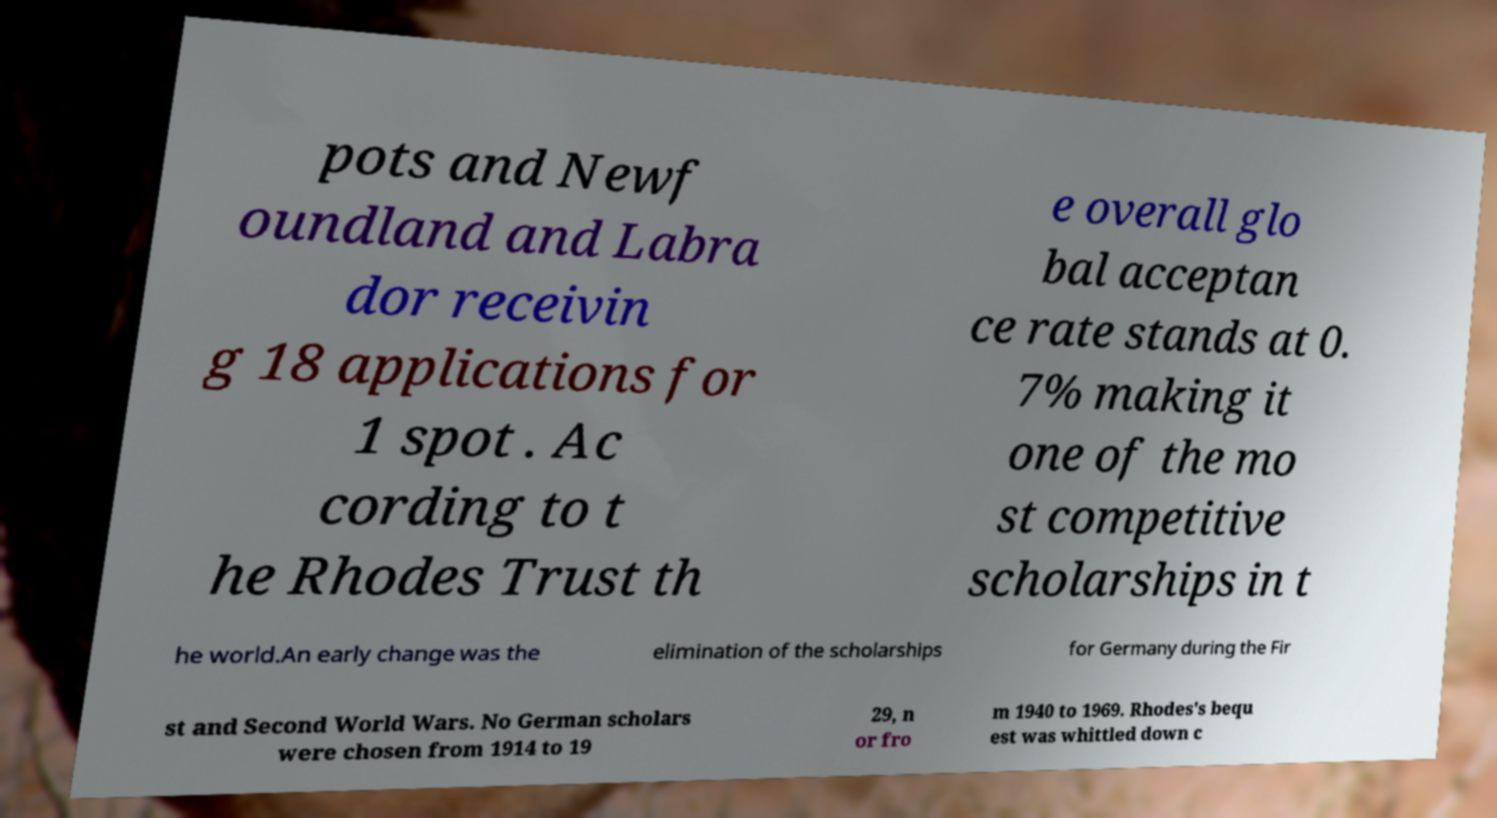Please identify and transcribe the text found in this image. pots and Newf oundland and Labra dor receivin g 18 applications for 1 spot . Ac cording to t he Rhodes Trust th e overall glo bal acceptan ce rate stands at 0. 7% making it one of the mo st competitive scholarships in t he world.An early change was the elimination of the scholarships for Germany during the Fir st and Second World Wars. No German scholars were chosen from 1914 to 19 29, n or fro m 1940 to 1969. Rhodes's bequ est was whittled down c 